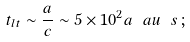Convert formula to latex. <formula><loc_0><loc_0><loc_500><loc_500>t _ { l t } \sim \frac { a } { c } \sim 5 \times 1 0 ^ { 2 } a _ { \ } a u \ s \, ;</formula> 